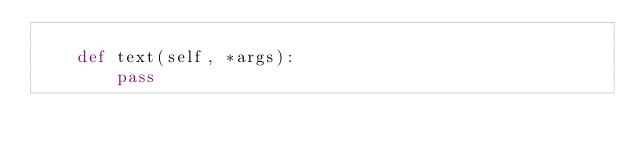<code> <loc_0><loc_0><loc_500><loc_500><_Python_>
    def text(self, *args):
        pass
</code> 